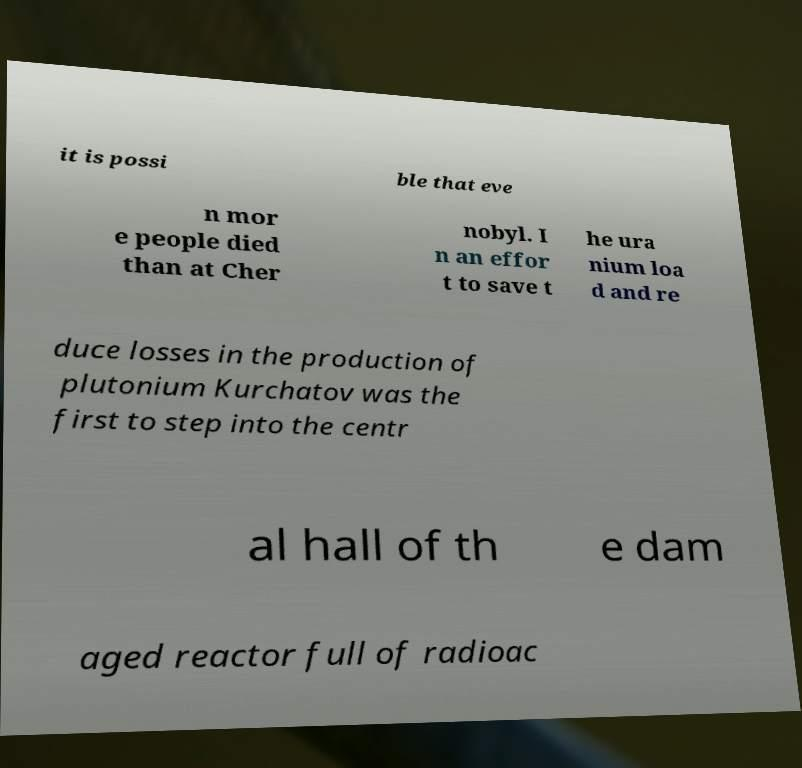What messages or text are displayed in this image? I need them in a readable, typed format. it is possi ble that eve n mor e people died than at Cher nobyl. I n an effor t to save t he ura nium loa d and re duce losses in the production of plutonium Kurchatov was the first to step into the centr al hall of th e dam aged reactor full of radioac 